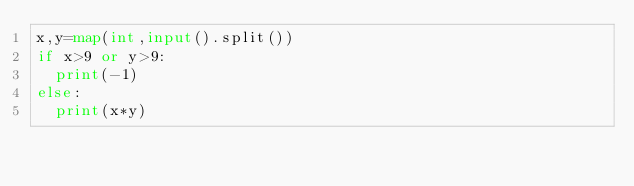Convert code to text. <code><loc_0><loc_0><loc_500><loc_500><_Python_>x,y=map(int,input().split())
if x>9 or y>9:
  print(-1)
else:
  print(x*y)</code> 